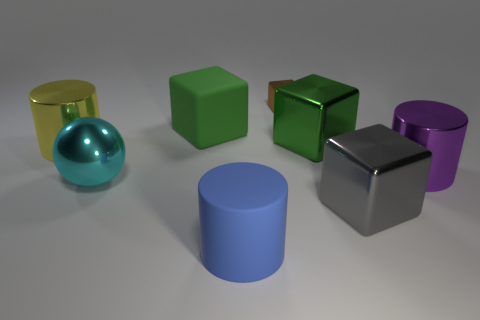Subtract 1 blocks. How many blocks are left? 3 Subtract all blue cubes. Subtract all green balls. How many cubes are left? 4 Add 1 big purple metallic objects. How many objects exist? 9 Subtract all cylinders. How many objects are left? 5 Add 4 big green rubber blocks. How many big green rubber blocks exist? 5 Subtract 1 green blocks. How many objects are left? 7 Subtract all big cyan shiny objects. Subtract all brown metal objects. How many objects are left? 6 Add 7 big metallic blocks. How many big metallic blocks are left? 9 